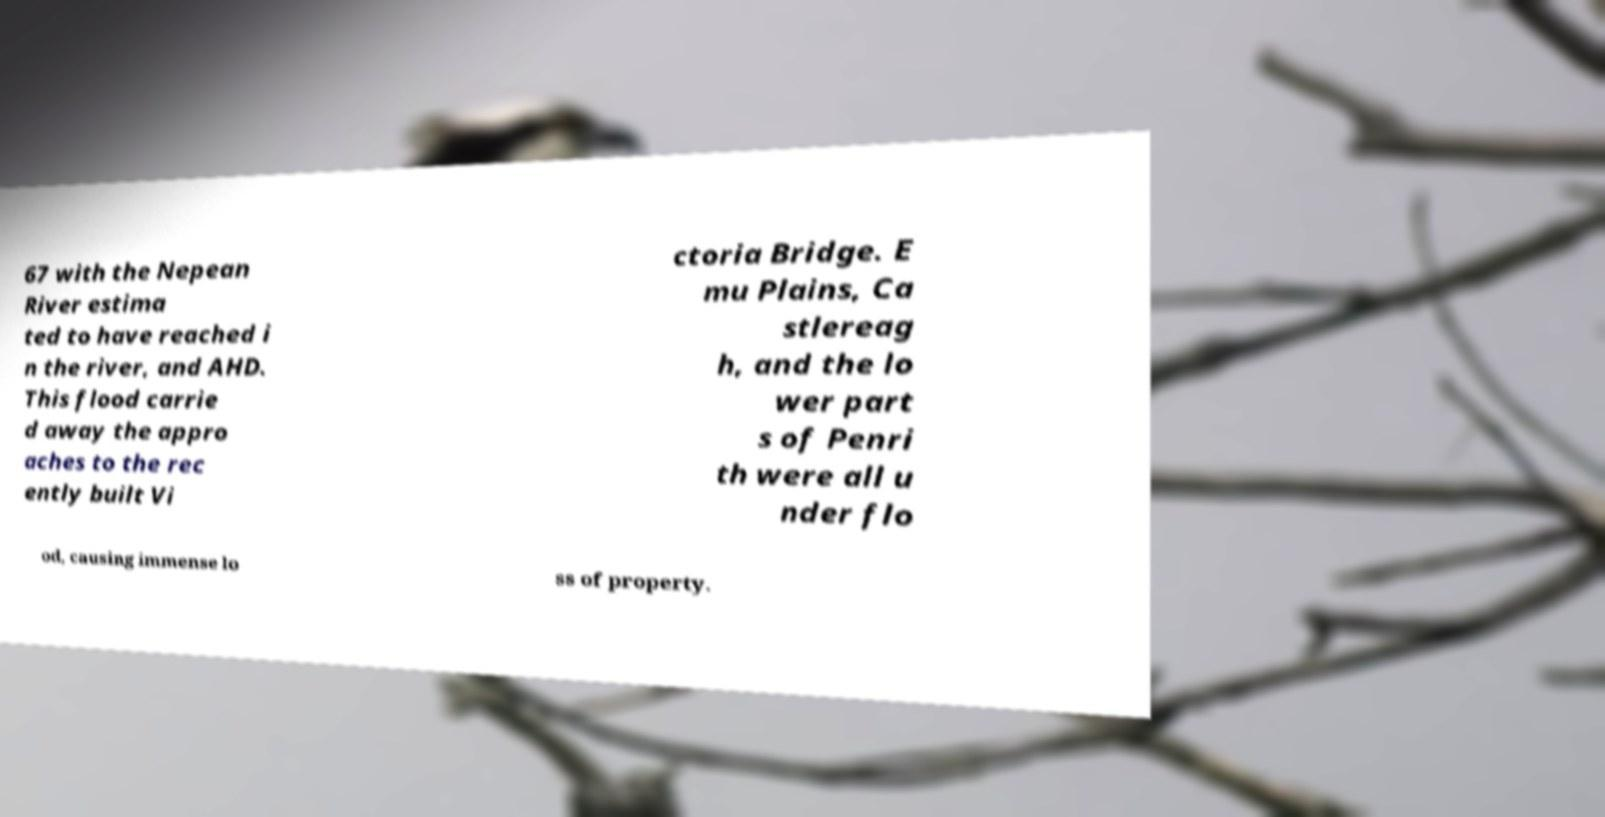Can you accurately transcribe the text from the provided image for me? 67 with the Nepean River estima ted to have reached i n the river, and AHD. This flood carrie d away the appro aches to the rec ently built Vi ctoria Bridge. E mu Plains, Ca stlereag h, and the lo wer part s of Penri th were all u nder flo od, causing immense lo ss of property. 